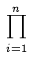<formula> <loc_0><loc_0><loc_500><loc_500>\prod _ { i = 1 } ^ { n }</formula> 